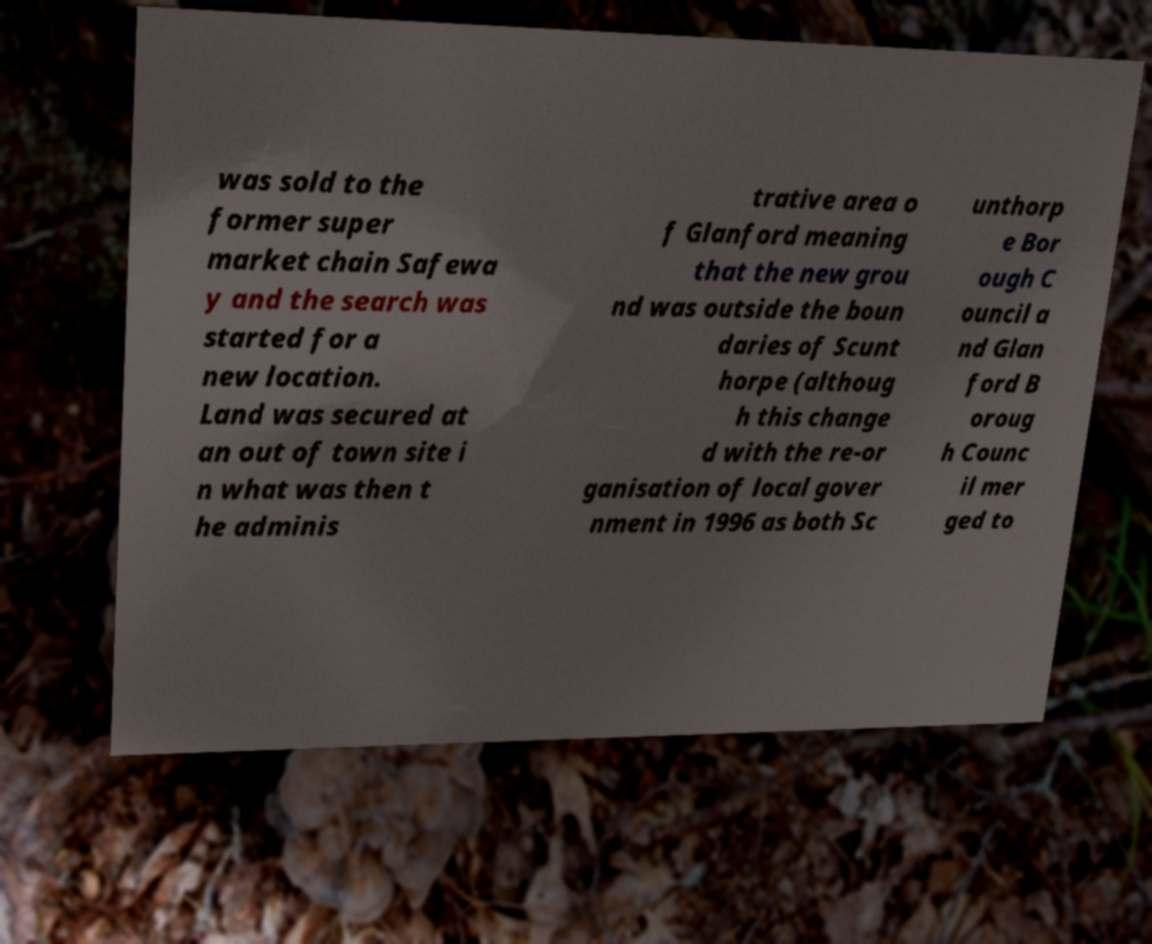There's text embedded in this image that I need extracted. Can you transcribe it verbatim? was sold to the former super market chain Safewa y and the search was started for a new location. Land was secured at an out of town site i n what was then t he adminis trative area o f Glanford meaning that the new grou nd was outside the boun daries of Scunt horpe (althoug h this change d with the re-or ganisation of local gover nment in 1996 as both Sc unthorp e Bor ough C ouncil a nd Glan ford B oroug h Counc il mer ged to 